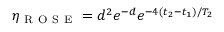<formula> <loc_0><loc_0><loc_500><loc_500>\eta _ { R O S E } = d ^ { 2 } e ^ { - d } e ^ { - 4 ( t _ { 2 } - t _ { 1 } ) / T _ { 2 } }</formula> 